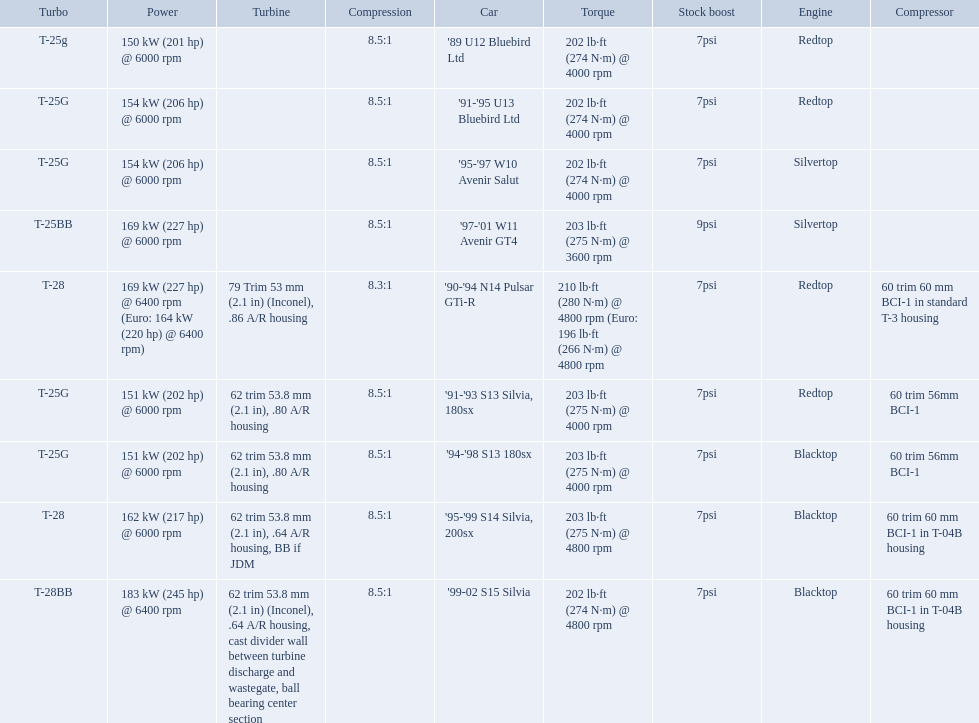What are all of the cars? '89 U12 Bluebird Ltd, '91-'95 U13 Bluebird Ltd, '95-'97 W10 Avenir Salut, '97-'01 W11 Avenir GT4, '90-'94 N14 Pulsar GTi-R, '91-'93 S13 Silvia, 180sx, '94-'98 S13 180sx, '95-'99 S14 Silvia, 200sx, '99-02 S15 Silvia. What is their rated power? 150 kW (201 hp) @ 6000 rpm, 154 kW (206 hp) @ 6000 rpm, 154 kW (206 hp) @ 6000 rpm, 169 kW (227 hp) @ 6000 rpm, 169 kW (227 hp) @ 6400 rpm (Euro: 164 kW (220 hp) @ 6400 rpm), 151 kW (202 hp) @ 6000 rpm, 151 kW (202 hp) @ 6000 rpm, 162 kW (217 hp) @ 6000 rpm, 183 kW (245 hp) @ 6400 rpm. Which car has the most power? '99-02 S15 Silvia. What are all of the nissan cars? '89 U12 Bluebird Ltd, '91-'95 U13 Bluebird Ltd, '95-'97 W10 Avenir Salut, '97-'01 W11 Avenir GT4, '90-'94 N14 Pulsar GTi-R, '91-'93 S13 Silvia, 180sx, '94-'98 S13 180sx, '95-'99 S14 Silvia, 200sx, '99-02 S15 Silvia. Of these cars, which one is a '90-'94 n14 pulsar gti-r? '90-'94 N14 Pulsar GTi-R. What is the compression of this car? 8.3:1. 